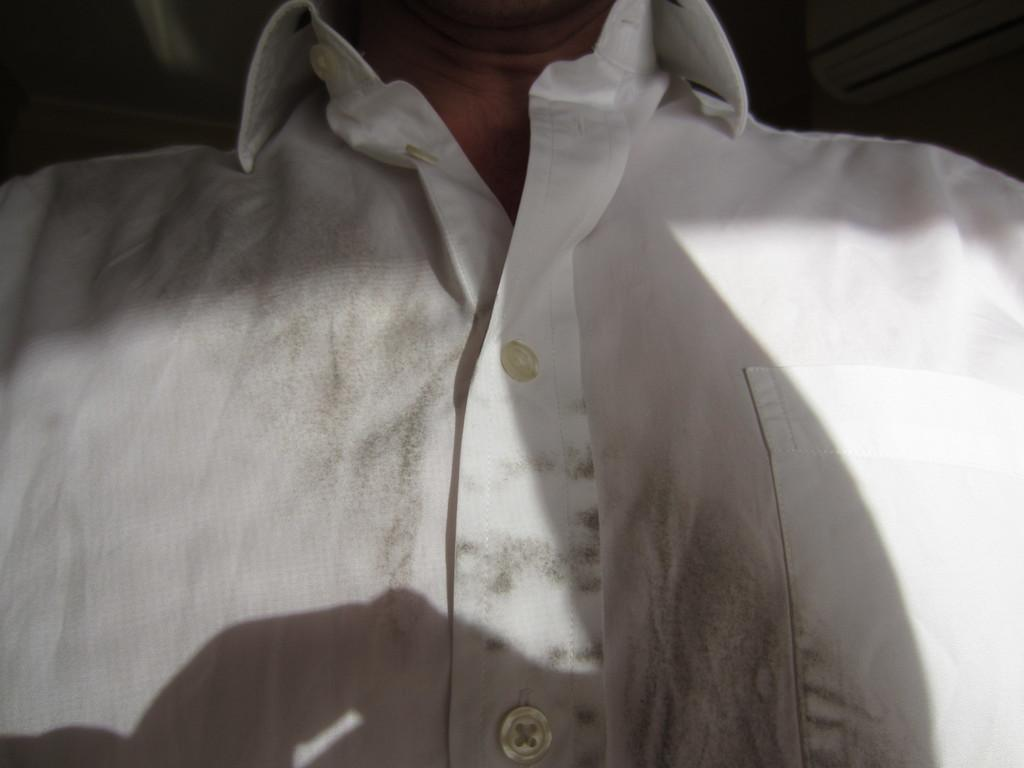What is the main subject of the image? There is a person in the image. Can you describe the person's clothing? The person is wearing a white shirt. What type of pleasure does the person in the image derive from their white shirt? There is no indication in the image that the person is experiencing any pleasure from their white shirt. 